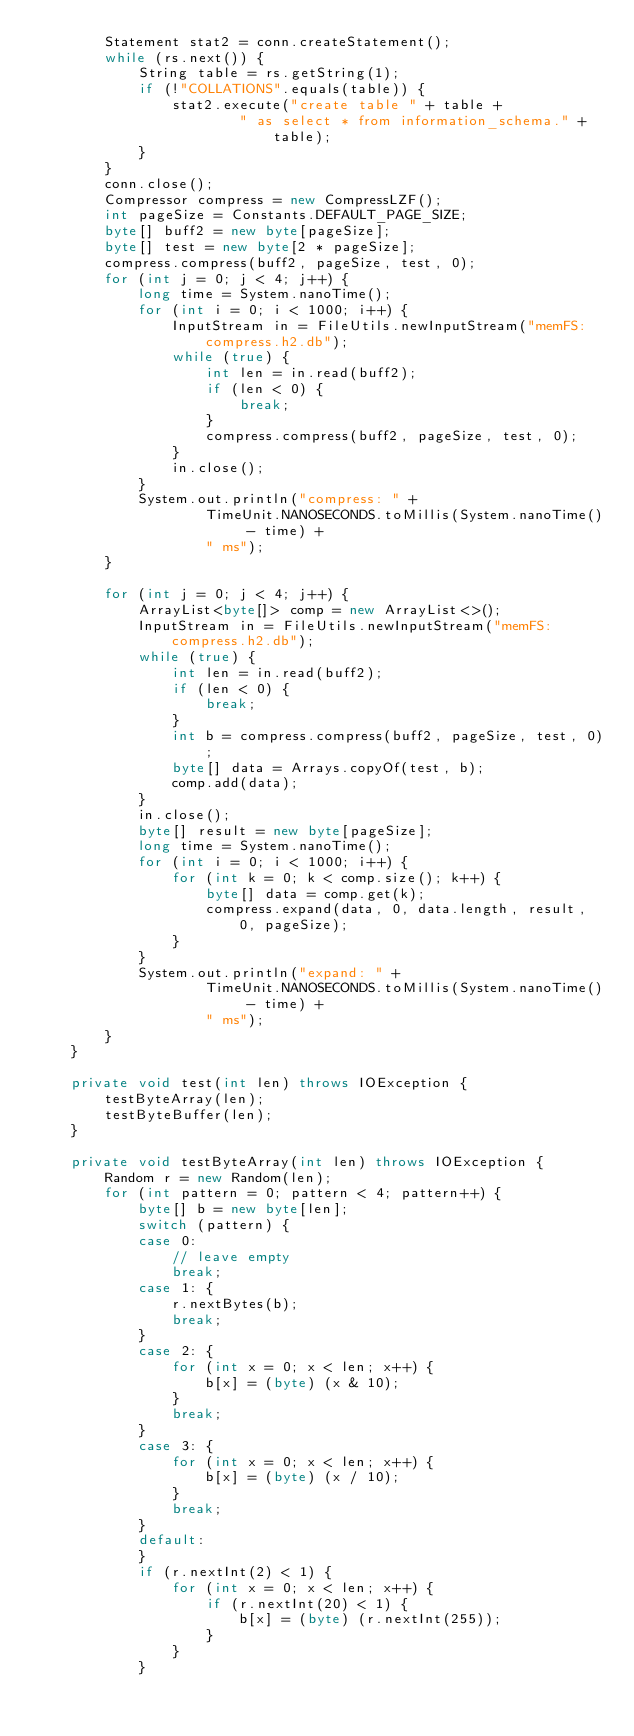Convert code to text. <code><loc_0><loc_0><loc_500><loc_500><_Java_>        Statement stat2 = conn.createStatement();
        while (rs.next()) {
            String table = rs.getString(1);
            if (!"COLLATIONS".equals(table)) {
                stat2.execute("create table " + table +
                        " as select * from information_schema." + table);
            }
        }
        conn.close();
        Compressor compress = new CompressLZF();
        int pageSize = Constants.DEFAULT_PAGE_SIZE;
        byte[] buff2 = new byte[pageSize];
        byte[] test = new byte[2 * pageSize];
        compress.compress(buff2, pageSize, test, 0);
        for (int j = 0; j < 4; j++) {
            long time = System.nanoTime();
            for (int i = 0; i < 1000; i++) {
                InputStream in = FileUtils.newInputStream("memFS:compress.h2.db");
                while (true) {
                    int len = in.read(buff2);
                    if (len < 0) {
                        break;
                    }
                    compress.compress(buff2, pageSize, test, 0);
                }
                in.close();
            }
            System.out.println("compress: " +
                    TimeUnit.NANOSECONDS.toMillis(System.nanoTime() - time) +
                    " ms");
        }

        for (int j = 0; j < 4; j++) {
            ArrayList<byte[]> comp = new ArrayList<>();
            InputStream in = FileUtils.newInputStream("memFS:compress.h2.db");
            while (true) {
                int len = in.read(buff2);
                if (len < 0) {
                    break;
                }
                int b = compress.compress(buff2, pageSize, test, 0);
                byte[] data = Arrays.copyOf(test, b);
                comp.add(data);
            }
            in.close();
            byte[] result = new byte[pageSize];
            long time = System.nanoTime();
            for (int i = 0; i < 1000; i++) {
                for (int k = 0; k < comp.size(); k++) {
                    byte[] data = comp.get(k);
                    compress.expand(data, 0, data.length, result, 0, pageSize);
                }
            }
            System.out.println("expand: " +
                    TimeUnit.NANOSECONDS.toMillis(System.nanoTime() - time) +
                    " ms");
        }
    }

    private void test(int len) throws IOException {
        testByteArray(len);
        testByteBuffer(len);
    }

    private void testByteArray(int len) throws IOException {
        Random r = new Random(len);
        for (int pattern = 0; pattern < 4; pattern++) {
            byte[] b = new byte[len];
            switch (pattern) {
            case 0:
                // leave empty
                break;
            case 1: {
                r.nextBytes(b);
                break;
            }
            case 2: {
                for (int x = 0; x < len; x++) {
                    b[x] = (byte) (x & 10);
                }
                break;
            }
            case 3: {
                for (int x = 0; x < len; x++) {
                    b[x] = (byte) (x / 10);
                }
                break;
            }
            default:
            }
            if (r.nextInt(2) < 1) {
                for (int x = 0; x < len; x++) {
                    if (r.nextInt(20) < 1) {
                        b[x] = (byte) (r.nextInt(255));
                    }
                }
            }</code> 